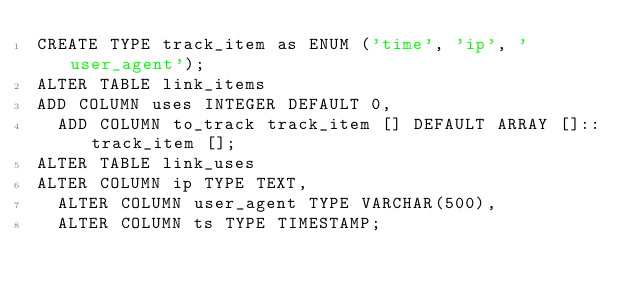Convert code to text. <code><loc_0><loc_0><loc_500><loc_500><_SQL_>CREATE TYPE track_item as ENUM ('time', 'ip', 'user_agent');
ALTER TABLE link_items
ADD COLUMN uses INTEGER DEFAULT 0,
  ADD COLUMN to_track track_item [] DEFAULT ARRAY []::track_item [];
ALTER TABLE link_uses
ALTER COLUMN ip TYPE TEXT,
  ALTER COLUMN user_agent TYPE VARCHAR(500),
  ALTER COLUMN ts TYPE TIMESTAMP;
</code> 